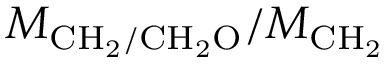Convert formula to latex. <formula><loc_0><loc_0><loc_500><loc_500>M _ { C H _ { 2 } / C H _ { 2 } O } / M _ { C H _ { 2 } }</formula> 